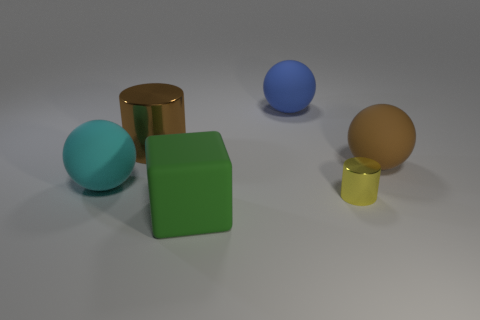Add 4 green blocks. How many objects exist? 10 Subtract all cylinders. How many objects are left? 4 Subtract 0 brown blocks. How many objects are left? 6 Subtract all big matte cubes. Subtract all rubber spheres. How many objects are left? 2 Add 5 big blue things. How many big blue things are left? 6 Add 5 metal cylinders. How many metal cylinders exist? 7 